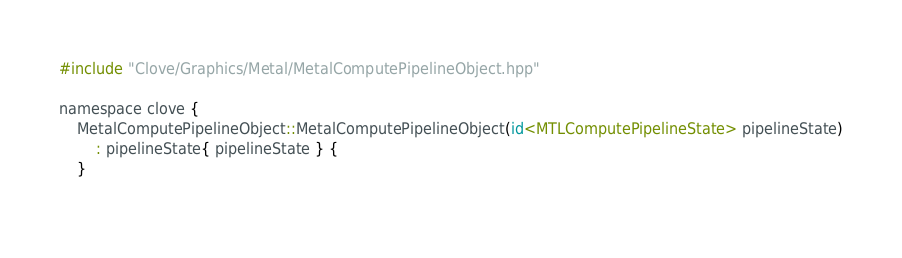<code> <loc_0><loc_0><loc_500><loc_500><_ObjectiveC_>#include "Clove/Graphics/Metal/MetalComputePipelineObject.hpp"

namespace clove {
	MetalComputePipelineObject::MetalComputePipelineObject(id<MTLComputePipelineState> pipelineState)
		: pipelineState{ pipelineState } {
	}
	</code> 